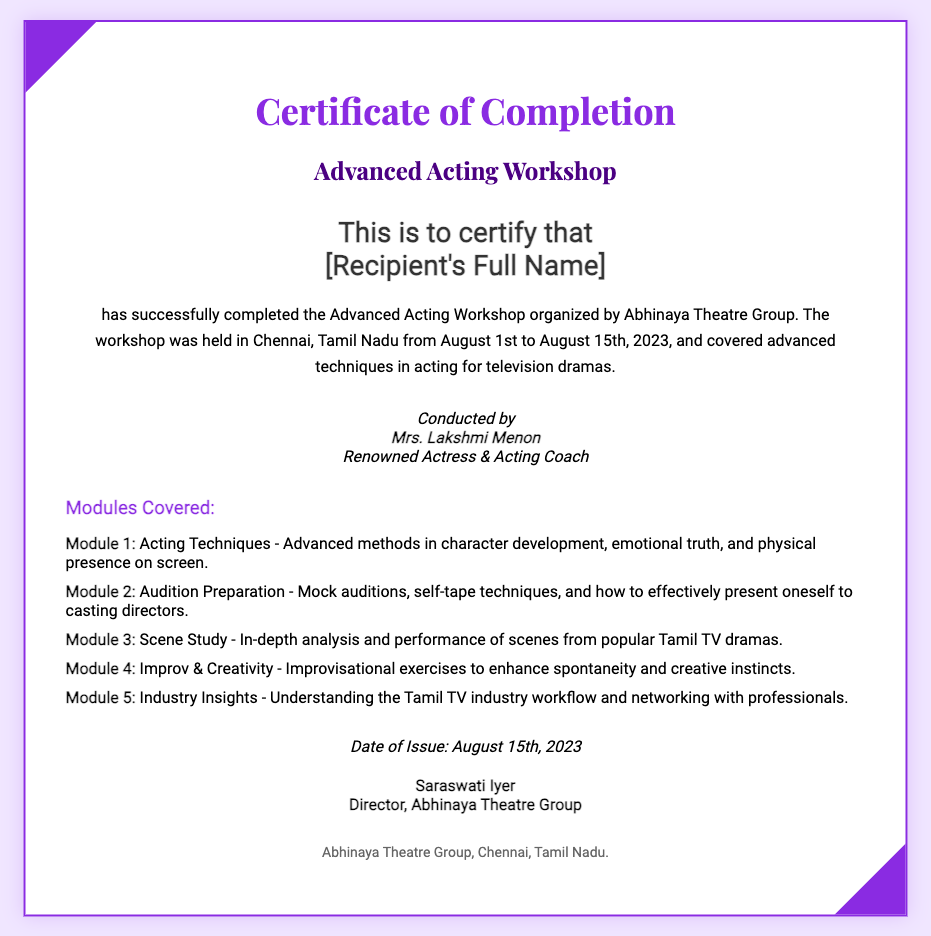what is the title of the workshop? The title of the workshop is prominently displayed in the document as "Advanced Acting Workshop."
Answer: Advanced Acting Workshop who conducted the workshop? The name of the person who conducted the workshop is mentioned as "Mrs. Lakshmi Menon."
Answer: Mrs. Lakshmi Menon when was the workshop held? The specific dates for the workshop are given as "August 1st to August 15th, 2023."
Answer: August 1st to August 15th, 2023 what is the name of the organization that issued the certificate? The organization name appears in the footer of the document as "Abhinaya Theatre Group."
Answer: Abhinaya Theatre Group how many modules were covered in the workshop? The document lists a total of five modules in the modules section.
Answer: 5 what type of techniques were covered in Module 1? The techniques covered in Module 1 are mentioned as "Advanced methods in character development, emotional truth, and physical presence on screen."
Answer: Advanced methods in character development, emotional truth, and physical presence on screen what was the date of issue for the certificate? The date of issue is clearly stated in the certificate as "August 15th, 2023."
Answer: August 15th, 2023 who is the director of the Abhinaya Theatre Group? The signature section identifies "Saraswati Iyer" as the director.
Answer: Saraswati Iyer what is emphasized in the "Industry Insights" module? The document mentions that the module focuses on "Understanding the Tamil TV industry workflow and networking with professionals."
Answer: Understanding the Tamil TV industry workflow and networking with professionals 